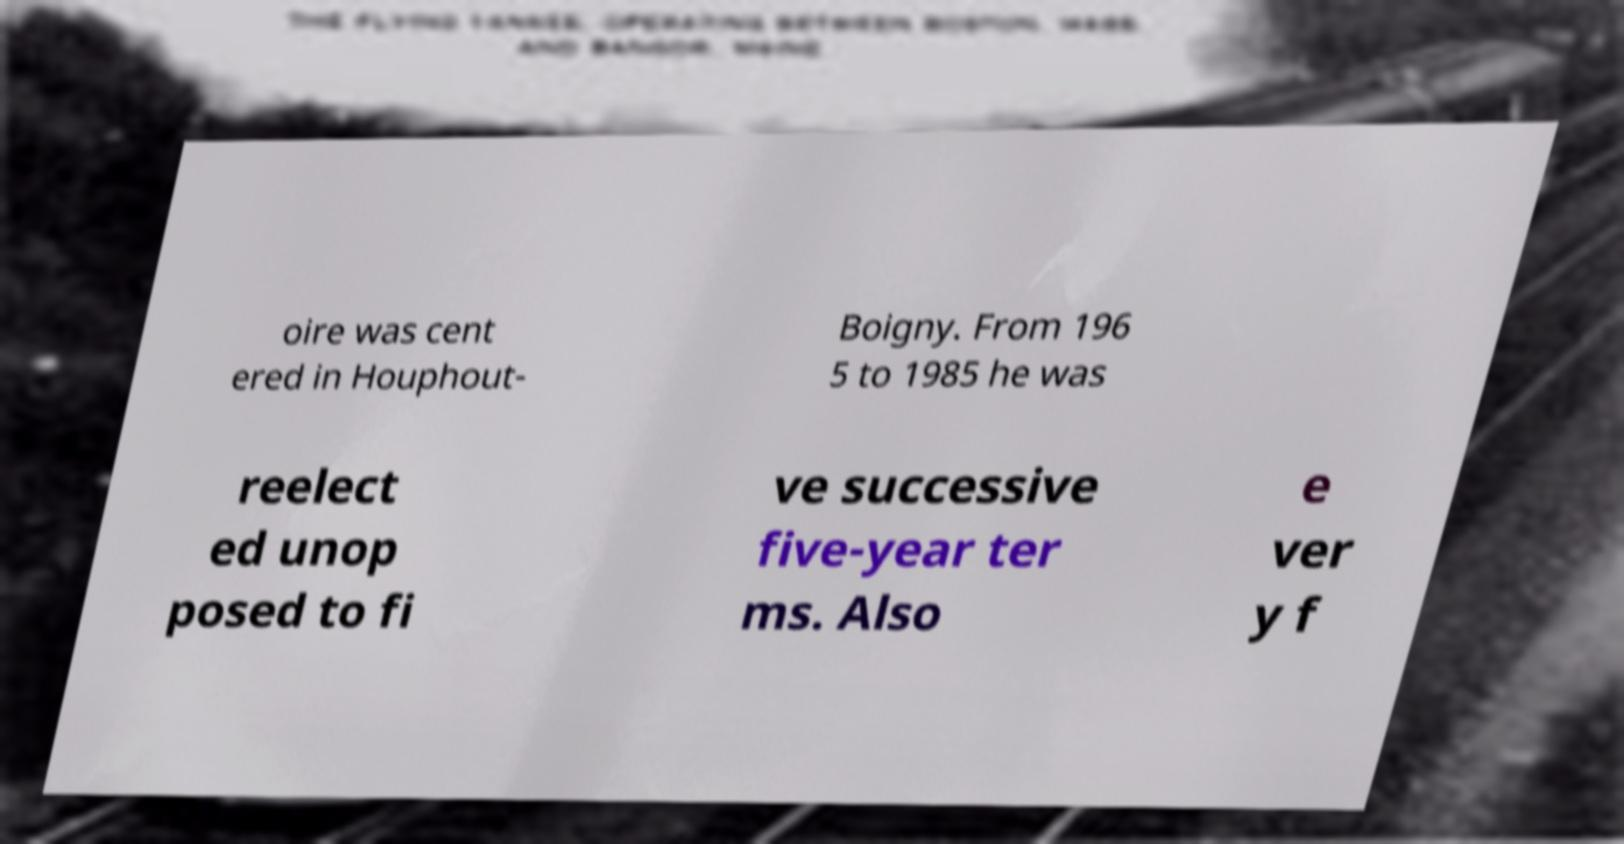Please read and relay the text visible in this image. What does it say? oire was cent ered in Houphout- Boigny. From 196 5 to 1985 he was reelect ed unop posed to fi ve successive five-year ter ms. Also e ver y f 